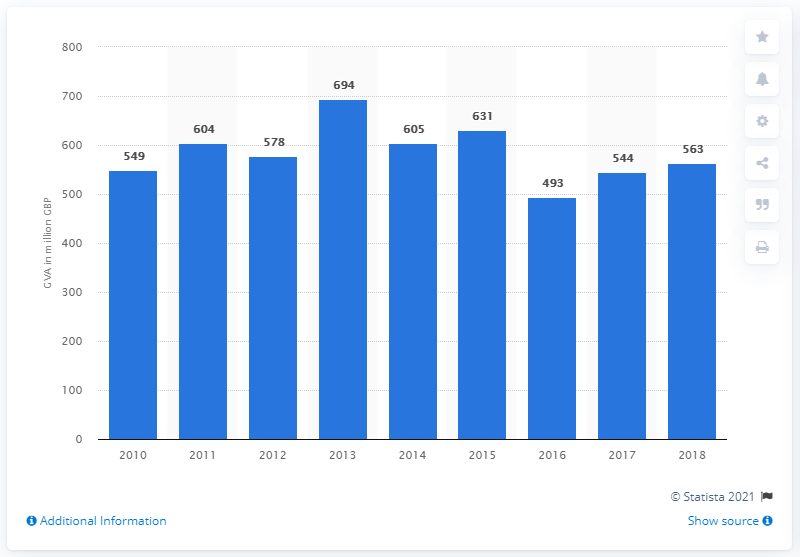Specify some key components in this picture. In 2018, the gross value added of the photography sector in the UK was 563 million pounds. 